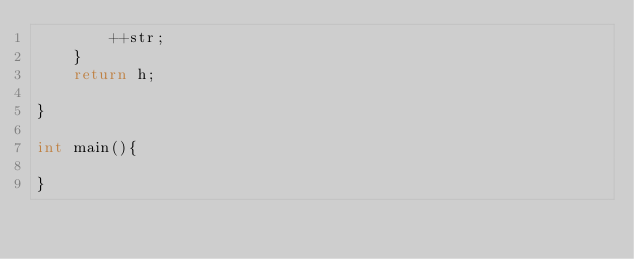Convert code to text. <code><loc_0><loc_0><loc_500><loc_500><_C_>		++str;
	}
	return h;

}

int main(){
  
}
</code> 